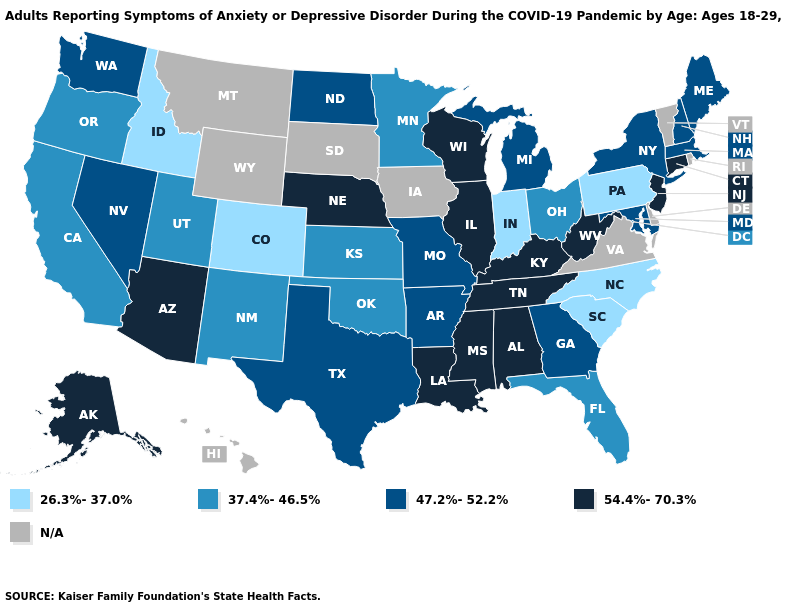Name the states that have a value in the range 26.3%-37.0%?
Answer briefly. Colorado, Idaho, Indiana, North Carolina, Pennsylvania, South Carolina. Name the states that have a value in the range 26.3%-37.0%?
Be succinct. Colorado, Idaho, Indiana, North Carolina, Pennsylvania, South Carolina. Name the states that have a value in the range 26.3%-37.0%?
Give a very brief answer. Colorado, Idaho, Indiana, North Carolina, Pennsylvania, South Carolina. What is the highest value in the Northeast ?
Short answer required. 54.4%-70.3%. Name the states that have a value in the range N/A?
Keep it brief. Delaware, Hawaii, Iowa, Montana, Rhode Island, South Dakota, Vermont, Virginia, Wyoming. What is the lowest value in the MidWest?
Answer briefly. 26.3%-37.0%. What is the lowest value in the USA?
Give a very brief answer. 26.3%-37.0%. Name the states that have a value in the range N/A?
Write a very short answer. Delaware, Hawaii, Iowa, Montana, Rhode Island, South Dakota, Vermont, Virginia, Wyoming. What is the value of Wyoming?
Give a very brief answer. N/A. What is the value of Minnesota?
Short answer required. 37.4%-46.5%. Among the states that border Arkansas , which have the lowest value?
Be succinct. Oklahoma. 